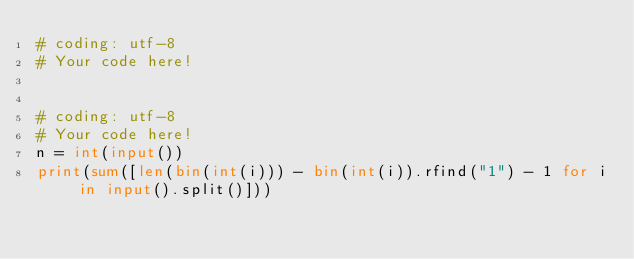Convert code to text. <code><loc_0><loc_0><loc_500><loc_500><_Python_># coding: utf-8
# Your code here!


# coding: utf-8
# Your code here!
n = int(input())
print(sum([len(bin(int(i))) - bin(int(i)).rfind("1") - 1 for i in input().split()]))

</code> 